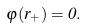Convert formula to latex. <formula><loc_0><loc_0><loc_500><loc_500>\varphi ( r _ { + } ) = 0 .</formula> 